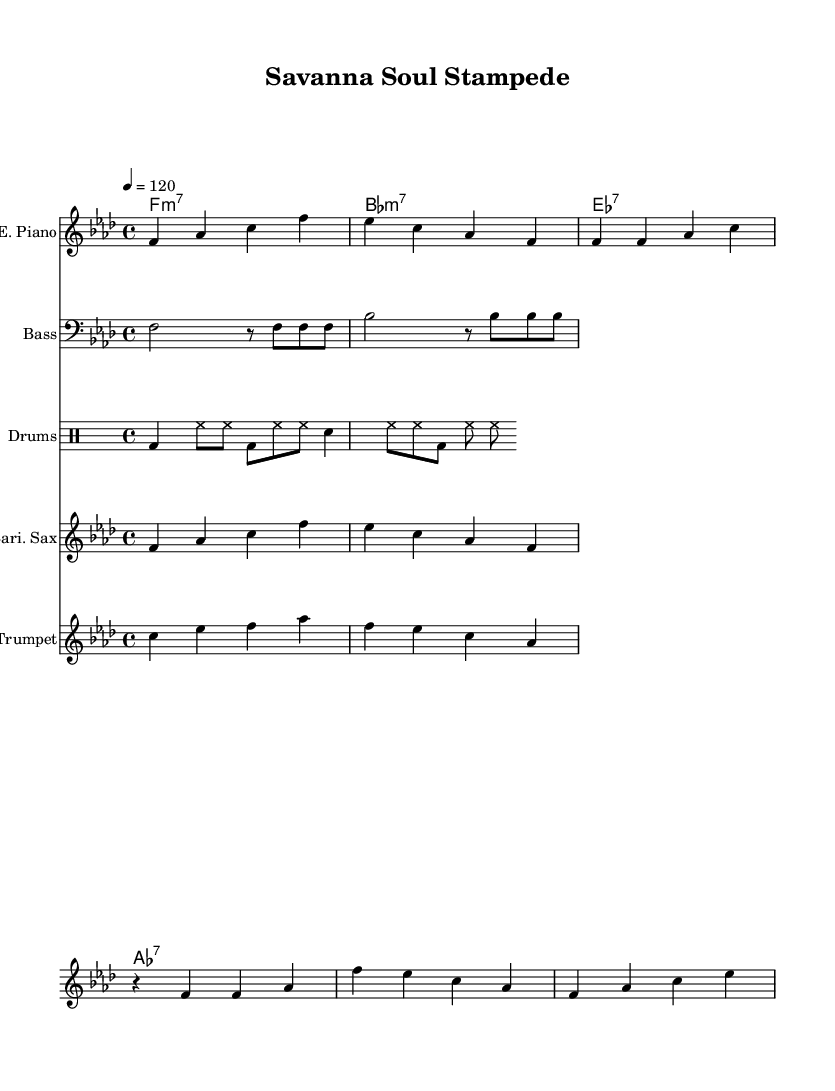What is the key signature of this music? The key is indicated at the beginning and has four flats, which corresponds to F minor.
Answer: F minor What is the time signature of this music? The time signature is present at the beginning of the score and shows four beats per measure, indicated by "4/4".
Answer: 4/4 What is the tempo marking for this piece? The tempo is specified at the start with "4 = 120", meaning there are 120 quarter-note beats per minute.
Answer: 120 How many distinct instruments are featured in this score? By counting the different staffs presented, there are five instruments: Electric Piano, Bass, Drums, Baritone Sax, and Trumpet.
Answer: Five What chords are used in the chorus section? The chord progression listed indicates the following: F minor 7, B flat minor 7, E flat 7, and A flat 7, all played in sequence.
Answer: F minor 7, B flat minor 7, E flat 7, A flat 7 What rhythmic pattern do the drums primarily utilize? The drumming part exhibits a consistent pattern, alternating between bass drum hits and hi-hat cymbals, commonly used in funk and soul genres.
Answer: Alternating bass drum and hi-hat What unique characteristic defines the melody of this piece? The melody in the baritone sax and trumpet parts showcases syncopation and expressive phrases, which are essential elements of funk and soul music.
Answer: Syncopation and expressive phrases 